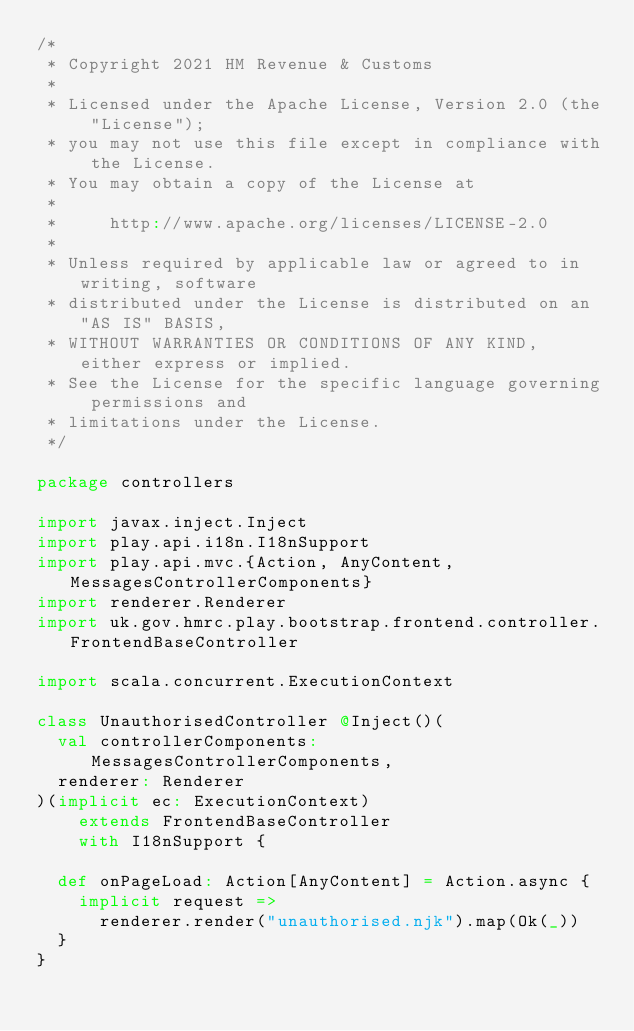<code> <loc_0><loc_0><loc_500><loc_500><_Scala_>/*
 * Copyright 2021 HM Revenue & Customs
 *
 * Licensed under the Apache License, Version 2.0 (the "License");
 * you may not use this file except in compliance with the License.
 * You may obtain a copy of the License at
 *
 *     http://www.apache.org/licenses/LICENSE-2.0
 *
 * Unless required by applicable law or agreed to in writing, software
 * distributed under the License is distributed on an "AS IS" BASIS,
 * WITHOUT WARRANTIES OR CONDITIONS OF ANY KIND, either express or implied.
 * See the License for the specific language governing permissions and
 * limitations under the License.
 */

package controllers

import javax.inject.Inject
import play.api.i18n.I18nSupport
import play.api.mvc.{Action, AnyContent, MessagesControllerComponents}
import renderer.Renderer
import uk.gov.hmrc.play.bootstrap.frontend.controller.FrontendBaseController

import scala.concurrent.ExecutionContext

class UnauthorisedController @Inject()(
  val controllerComponents: MessagesControllerComponents,
  renderer: Renderer
)(implicit ec: ExecutionContext)
    extends FrontendBaseController
    with I18nSupport {

  def onPageLoad: Action[AnyContent] = Action.async {
    implicit request =>
      renderer.render("unauthorised.njk").map(Ok(_))
  }
}
</code> 